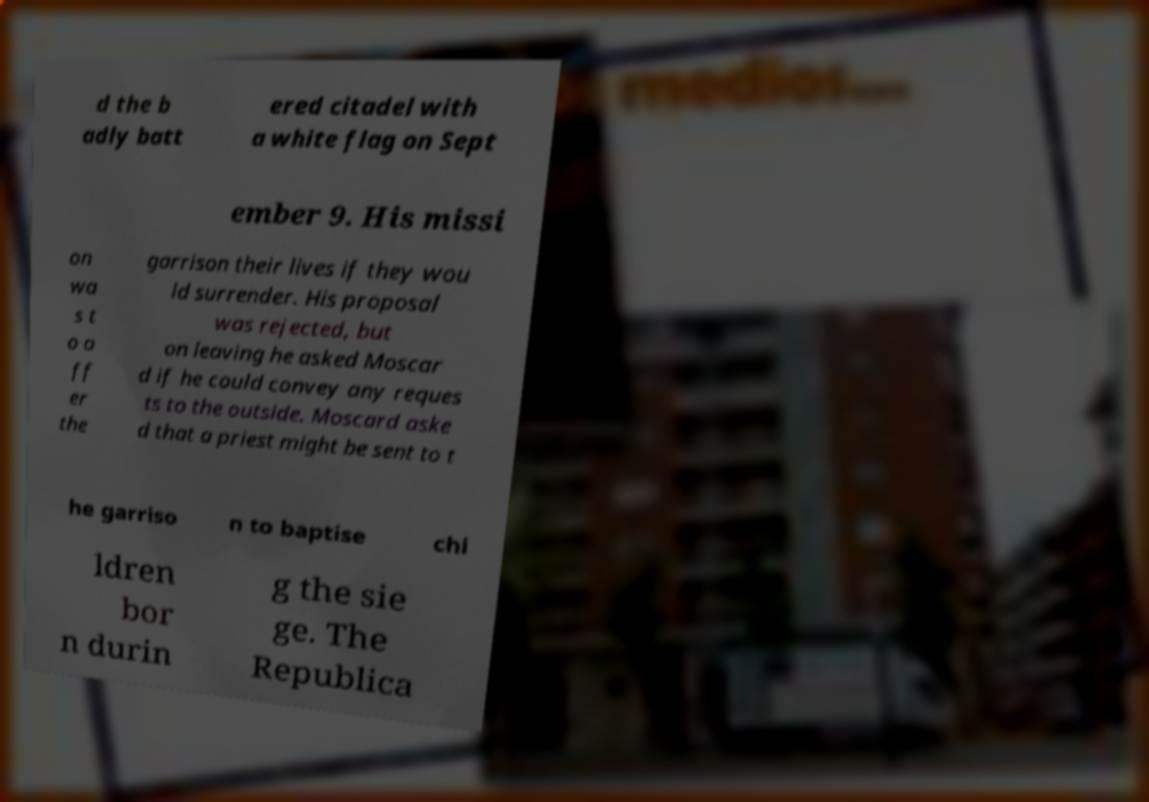Could you assist in decoding the text presented in this image and type it out clearly? d the b adly batt ered citadel with a white flag on Sept ember 9. His missi on wa s t o o ff er the garrison their lives if they wou ld surrender. His proposal was rejected, but on leaving he asked Moscar d if he could convey any reques ts to the outside. Moscard aske d that a priest might be sent to t he garriso n to baptise chi ldren bor n durin g the sie ge. The Republica 